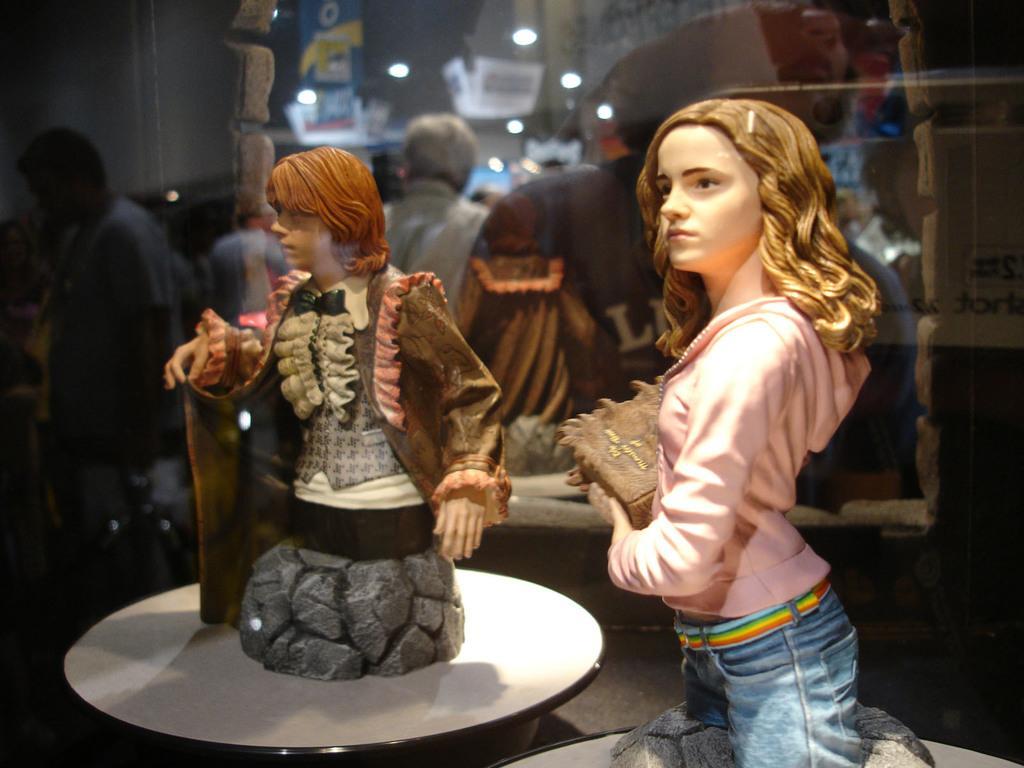Can you describe this image briefly? This image is clicked inside a room. There are two dolls in this image. To the light, the doll is having a pink shirt and blue jeans. To the left, the doll is having a brown jacket. In the background, there is a mirror and wall. 